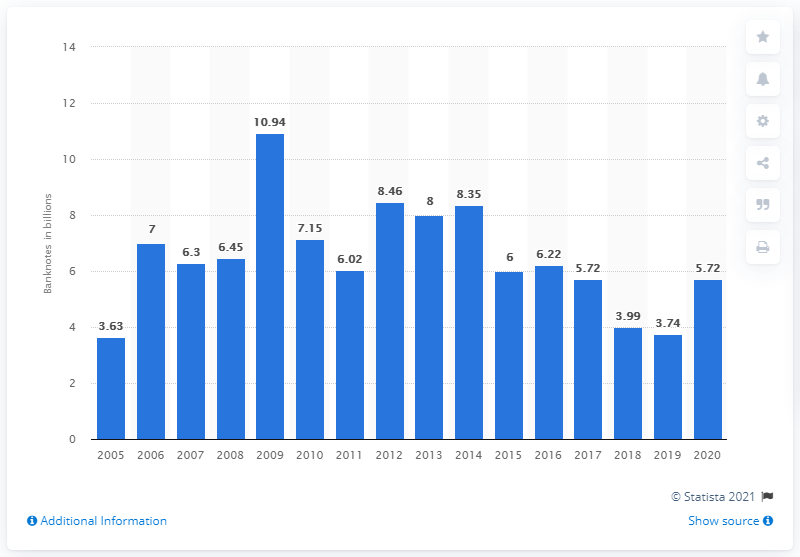Indicate a few pertinent items in this graphic. The smallest volume of euro banknotes was produced in 2005. In 2020, the total volume of euro banknotes produced was 5.72 billion. The largest volume of euro banknotes was produced in 2009. 